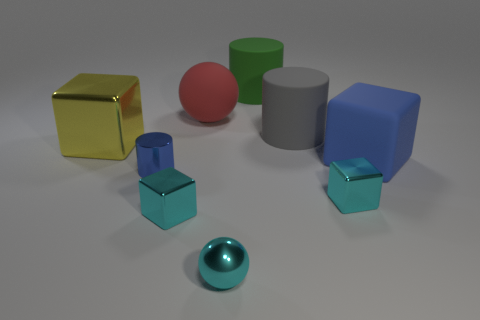Subtract all cyan blocks. How many were subtracted if there are1cyan blocks left? 1 Subtract all large gray cylinders. How many cylinders are left? 2 Subtract all yellow cubes. How many cubes are left? 3 Add 1 cyan matte balls. How many objects exist? 10 Subtract 2 cylinders. How many cylinders are left? 1 Subtract all cyan spheres. How many blue cylinders are left? 1 Add 5 green matte cylinders. How many green matte cylinders are left? 6 Add 1 cyan metallic things. How many cyan metallic things exist? 4 Subtract 0 yellow balls. How many objects are left? 9 Subtract all cubes. How many objects are left? 5 